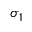Convert formula to latex. <formula><loc_0><loc_0><loc_500><loc_500>\sigma _ { 1 }</formula> 